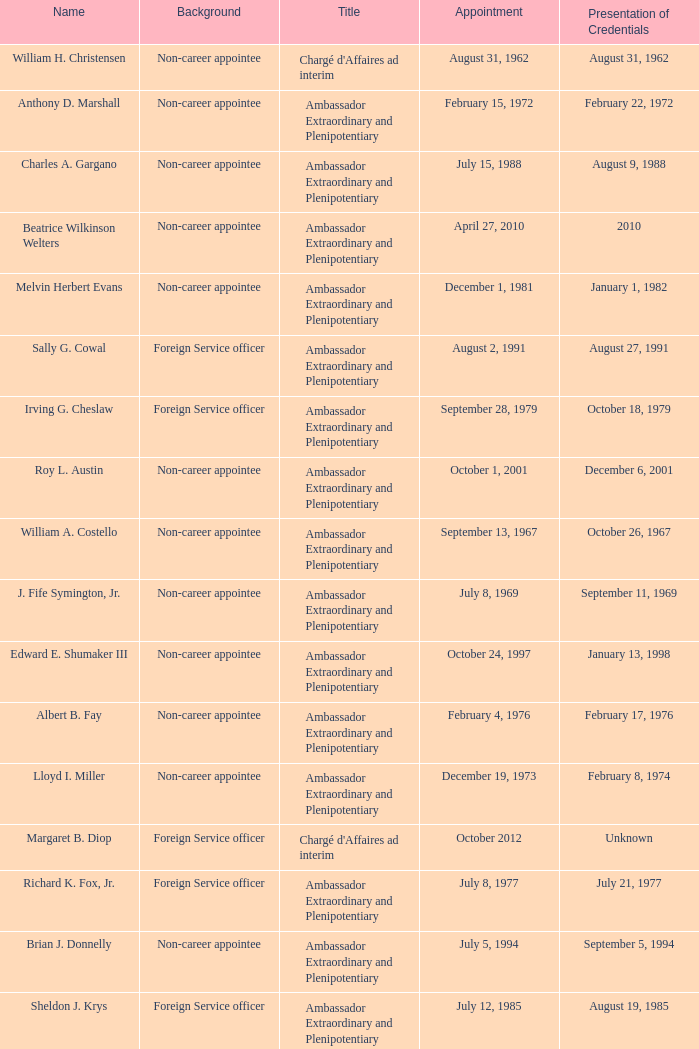At an unspecified date, who submitted their credentials? Margaret B. Diop. 